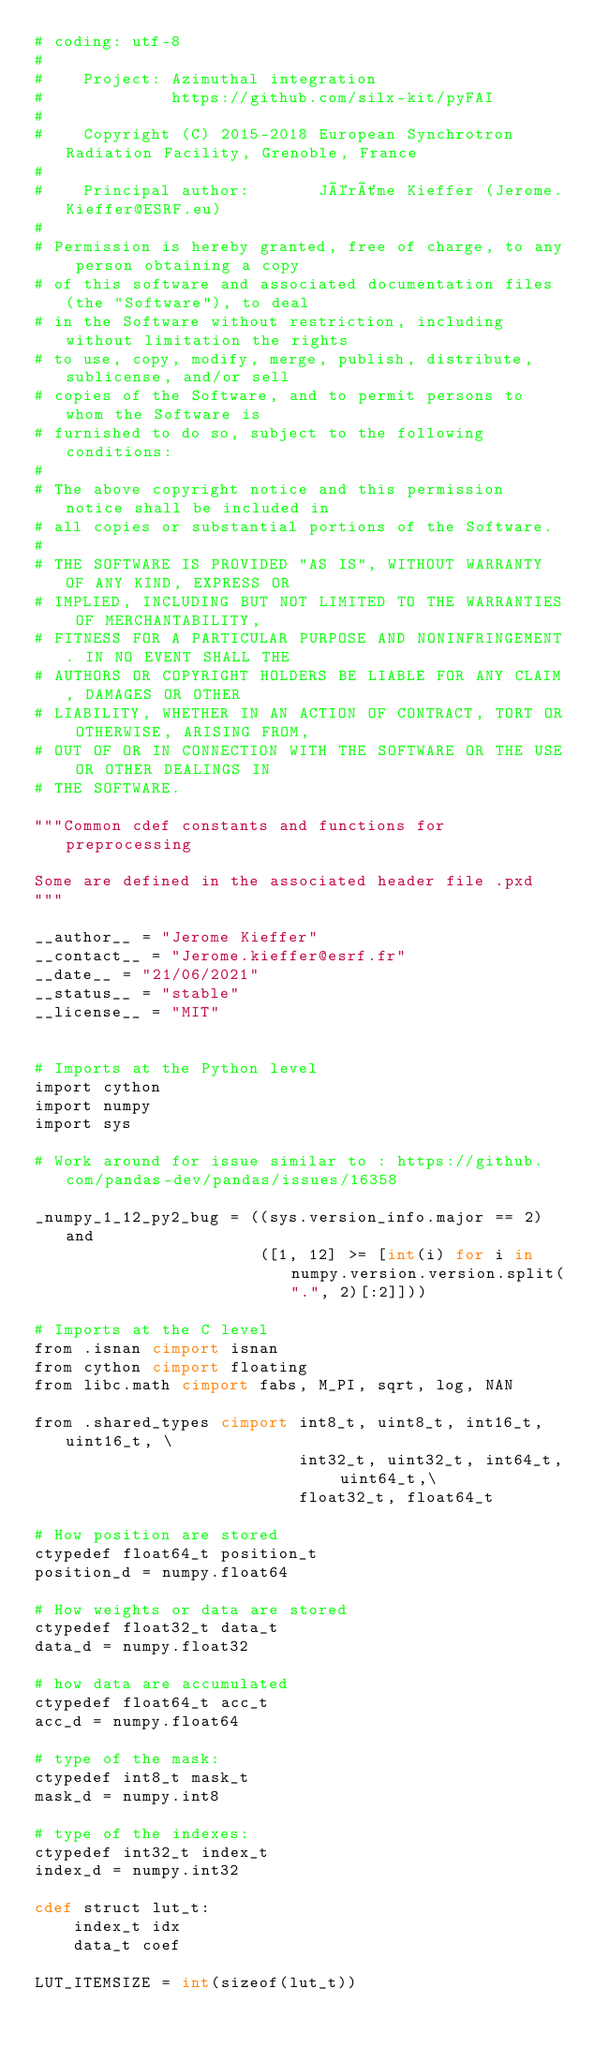<code> <loc_0><loc_0><loc_500><loc_500><_Cython_># coding: utf-8
#
#    Project: Azimuthal integration
#             https://github.com/silx-kit/pyFAI
#
#    Copyright (C) 2015-2018 European Synchrotron Radiation Facility, Grenoble, France
#
#    Principal author:       Jérôme Kieffer (Jerome.Kieffer@ESRF.eu)
#
# Permission is hereby granted, free of charge, to any person obtaining a copy
# of this software and associated documentation files (the "Software"), to deal
# in the Software without restriction, including without limitation the rights
# to use, copy, modify, merge, publish, distribute, sublicense, and/or sell
# copies of the Software, and to permit persons to whom the Software is
# furnished to do so, subject to the following conditions:
#
# The above copyright notice and this permission notice shall be included in
# all copies or substantial portions of the Software.
#
# THE SOFTWARE IS PROVIDED "AS IS", WITHOUT WARRANTY OF ANY KIND, EXPRESS OR
# IMPLIED, INCLUDING BUT NOT LIMITED TO THE WARRANTIES OF MERCHANTABILITY,
# FITNESS FOR A PARTICULAR PURPOSE AND NONINFRINGEMENT. IN NO EVENT SHALL THE
# AUTHORS OR COPYRIGHT HOLDERS BE LIABLE FOR ANY CLAIM, DAMAGES OR OTHER
# LIABILITY, WHETHER IN AN ACTION OF CONTRACT, TORT OR OTHERWISE, ARISING FROM,
# OUT OF OR IN CONNECTION WITH THE SOFTWARE OR THE USE OR OTHER DEALINGS IN
# THE SOFTWARE.

"""Common cdef constants and functions for preprocessing

Some are defined in the associated header file .pxd 
"""

__author__ = "Jerome Kieffer"
__contact__ = "Jerome.kieffer@esrf.fr"
__date__ = "21/06/2021"
__status__ = "stable"
__license__ = "MIT"


# Imports at the Python level 
import cython
import numpy
import sys

# Work around for issue similar to : https://github.com/pandas-dev/pandas/issues/16358

_numpy_1_12_py2_bug = ((sys.version_info.major == 2) and 
                       ([1, 12] >= [int(i) for i in numpy.version.version.split(".", 2)[:2]]))

# Imports at the C level
from .isnan cimport isnan
from cython cimport floating
from libc.math cimport fabs, M_PI, sqrt, log, NAN

from .shared_types cimport int8_t, uint8_t, int16_t, uint16_t, \
                           int32_t, uint32_t, int64_t, uint64_t,\
                           float32_t, float64_t

# How position are stored
ctypedef float64_t position_t
position_d = numpy.float64

# How weights or data are stored 
ctypedef float32_t data_t
data_d = numpy.float32

# how data are accumulated 
ctypedef float64_t acc_t
acc_d = numpy.float64

# type of the mask:
ctypedef int8_t mask_t
mask_d = numpy.int8

# type of the indexes:
ctypedef int32_t index_t
index_d = numpy.int32

cdef struct lut_t:
    index_t idx
    data_t coef

LUT_ITEMSIZE = int(sizeof(lut_t))
</code> 